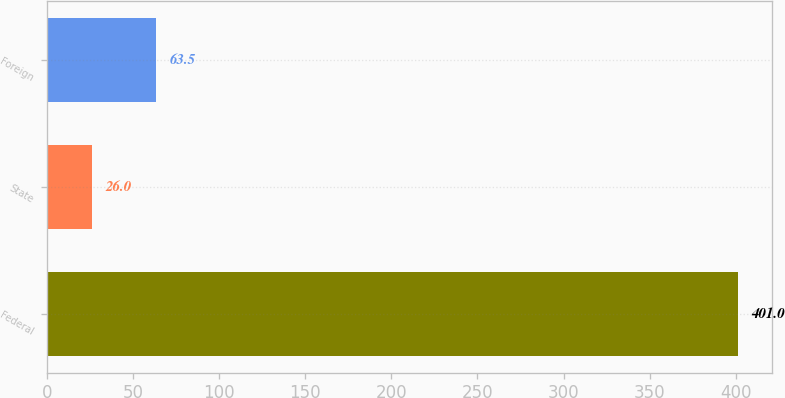Convert chart to OTSL. <chart><loc_0><loc_0><loc_500><loc_500><bar_chart><fcel>Federal<fcel>State<fcel>Foreign<nl><fcel>401<fcel>26<fcel>63.5<nl></chart> 